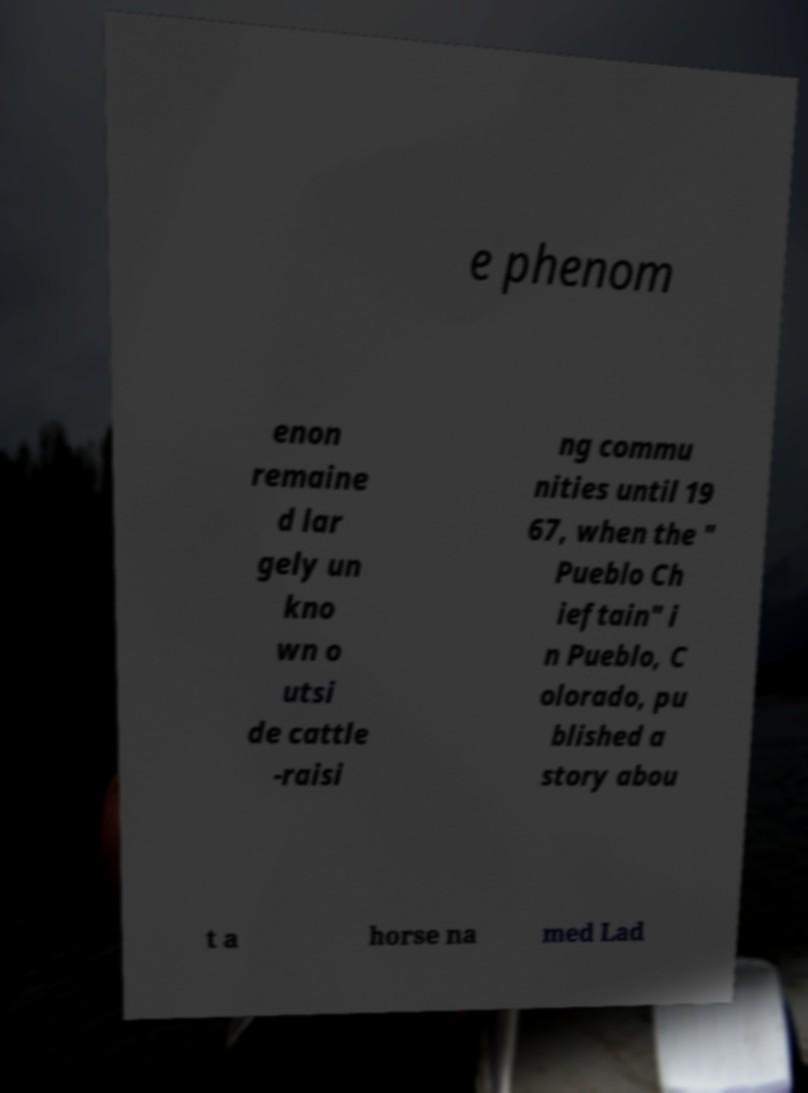Please identify and transcribe the text found in this image. e phenom enon remaine d lar gely un kno wn o utsi de cattle -raisi ng commu nities until 19 67, when the " Pueblo Ch ieftain" i n Pueblo, C olorado, pu blished a story abou t a horse na med Lad 